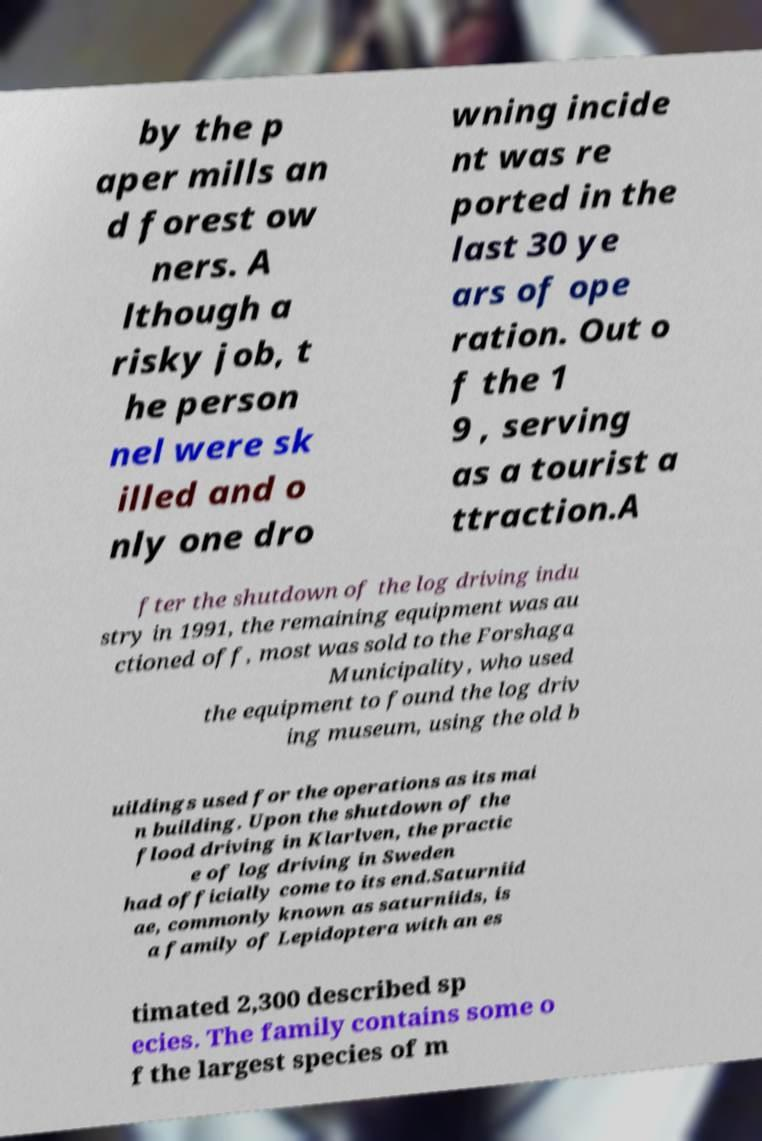There's text embedded in this image that I need extracted. Can you transcribe it verbatim? by the p aper mills an d forest ow ners. A lthough a risky job, t he person nel were sk illed and o nly one dro wning incide nt was re ported in the last 30 ye ars of ope ration. Out o f the 1 9 , serving as a tourist a ttraction.A fter the shutdown of the log driving indu stry in 1991, the remaining equipment was au ctioned off, most was sold to the Forshaga Municipality, who used the equipment to found the log driv ing museum, using the old b uildings used for the operations as its mai n building. Upon the shutdown of the flood driving in Klarlven, the practic e of log driving in Sweden had officially come to its end.Saturniid ae, commonly known as saturniids, is a family of Lepidoptera with an es timated 2,300 described sp ecies. The family contains some o f the largest species of m 